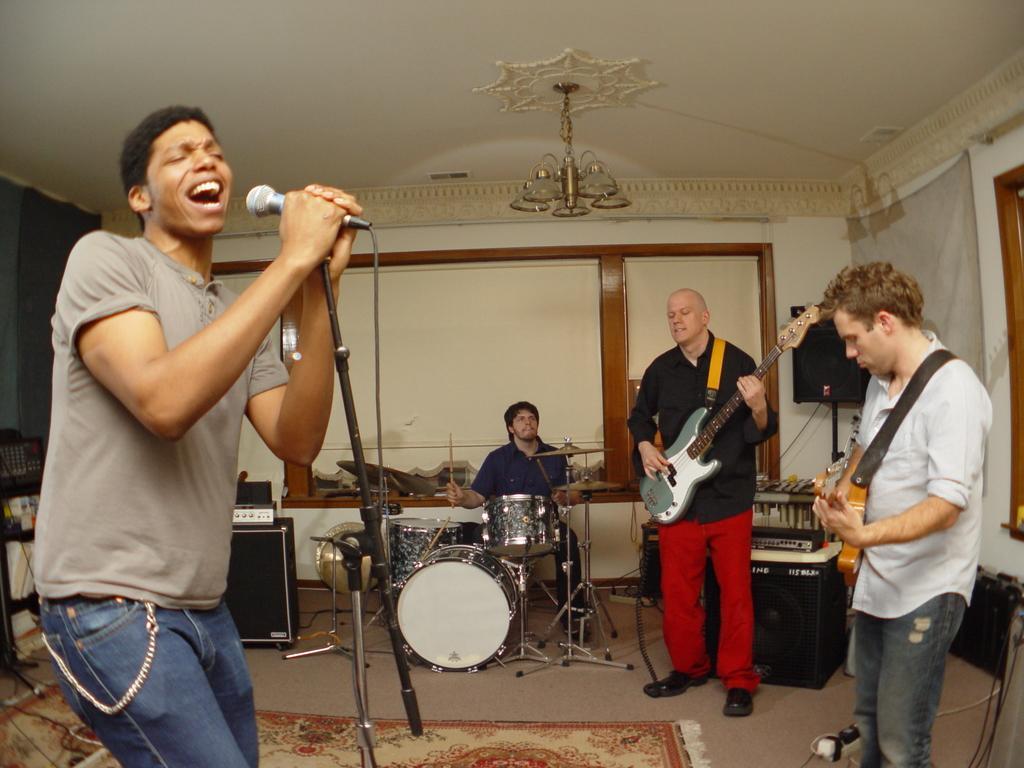How would you summarize this image in a sentence or two? This picture describes about group of people in the left side of the given image a man is singing with the help of microphone, in the middle of the image a person is seated on the chair and playing drums, the right side of the image, the persons are playing guitar. 